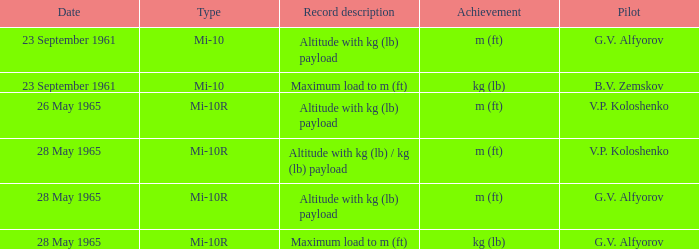What type of altitude record, with a payload in kg (lb), was set by a pilot named g.v. alfyorov? Mi-10, Mi-10R. 